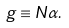<formula> <loc_0><loc_0><loc_500><loc_500>g \equiv N \alpha .</formula> 